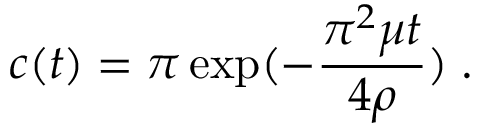<formula> <loc_0><loc_0><loc_500><loc_500>c ( t ) = \pi \exp ( - \frac { \pi ^ { 2 } \mu t } { 4 \rho } ) \, .</formula> 